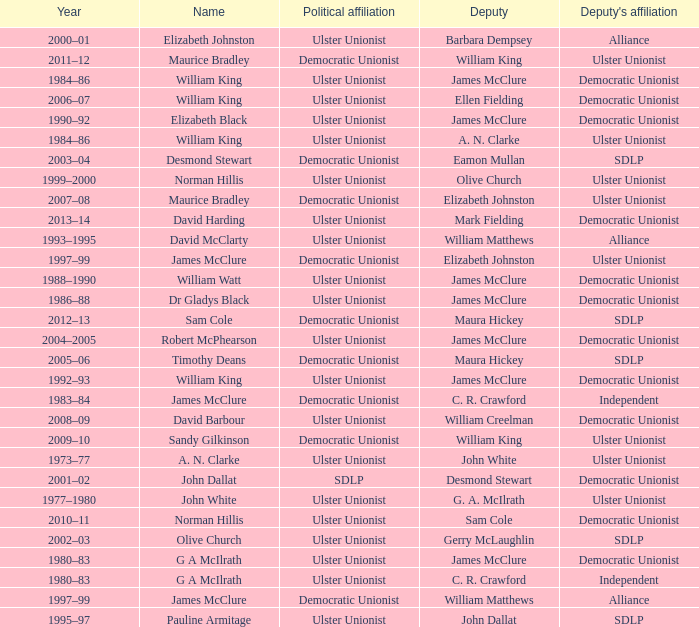What is the Political affiliation of deputy john dallat? Ulster Unionist. 